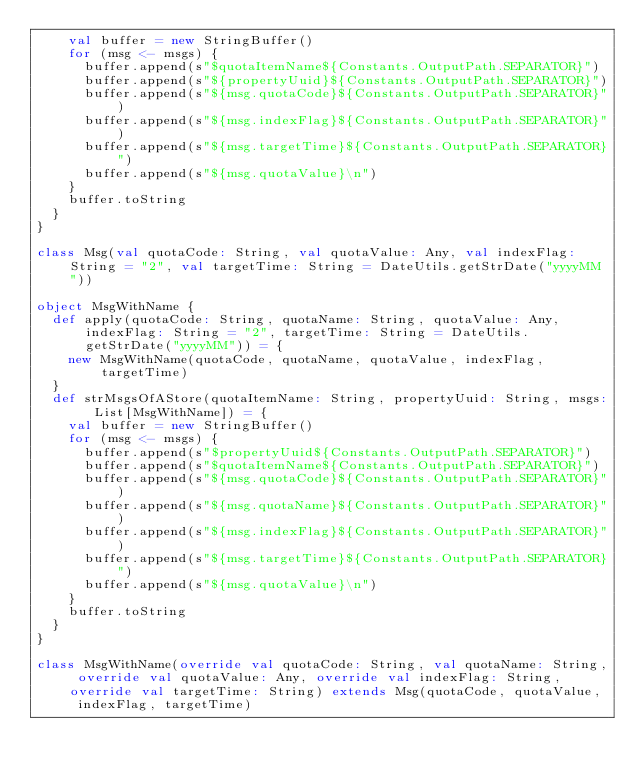Convert code to text. <code><loc_0><loc_0><loc_500><loc_500><_Scala_>    val buffer = new StringBuffer()
    for (msg <- msgs) {
      buffer.append(s"$quotaItemName${Constants.OutputPath.SEPARATOR}")
      buffer.append(s"${propertyUuid}${Constants.OutputPath.SEPARATOR}")
      buffer.append(s"${msg.quotaCode}${Constants.OutputPath.SEPARATOR}")
      buffer.append(s"${msg.indexFlag}${Constants.OutputPath.SEPARATOR}")
      buffer.append(s"${msg.targetTime}${Constants.OutputPath.SEPARATOR}")
      buffer.append(s"${msg.quotaValue}\n")
    }
    buffer.toString
  }
}

class Msg(val quotaCode: String, val quotaValue: Any, val indexFlag: String = "2", val targetTime: String = DateUtils.getStrDate("yyyyMM"))

object MsgWithName {
  def apply(quotaCode: String, quotaName: String, quotaValue: Any, indexFlag: String = "2", targetTime: String = DateUtils.getStrDate("yyyyMM")) = {
    new MsgWithName(quotaCode, quotaName, quotaValue, indexFlag, targetTime)
  }
  def strMsgsOfAStore(quotaItemName: String, propertyUuid: String, msgs: List[MsgWithName]) = {
    val buffer = new StringBuffer()
    for (msg <- msgs) {
      buffer.append(s"$propertyUuid${Constants.OutputPath.SEPARATOR}")
      buffer.append(s"$quotaItemName${Constants.OutputPath.SEPARATOR}")
      buffer.append(s"${msg.quotaCode}${Constants.OutputPath.SEPARATOR}")
      buffer.append(s"${msg.quotaName}${Constants.OutputPath.SEPARATOR}")
      buffer.append(s"${msg.indexFlag}${Constants.OutputPath.SEPARATOR}")
      buffer.append(s"${msg.targetTime}${Constants.OutputPath.SEPARATOR}")
      buffer.append(s"${msg.quotaValue}\n")
    }
    buffer.toString
  }
}

class MsgWithName(override val quotaCode: String, val quotaName: String, override val quotaValue: Any, override val indexFlag: String, override val targetTime: String) extends Msg(quotaCode, quotaValue, indexFlag, targetTime)</code> 